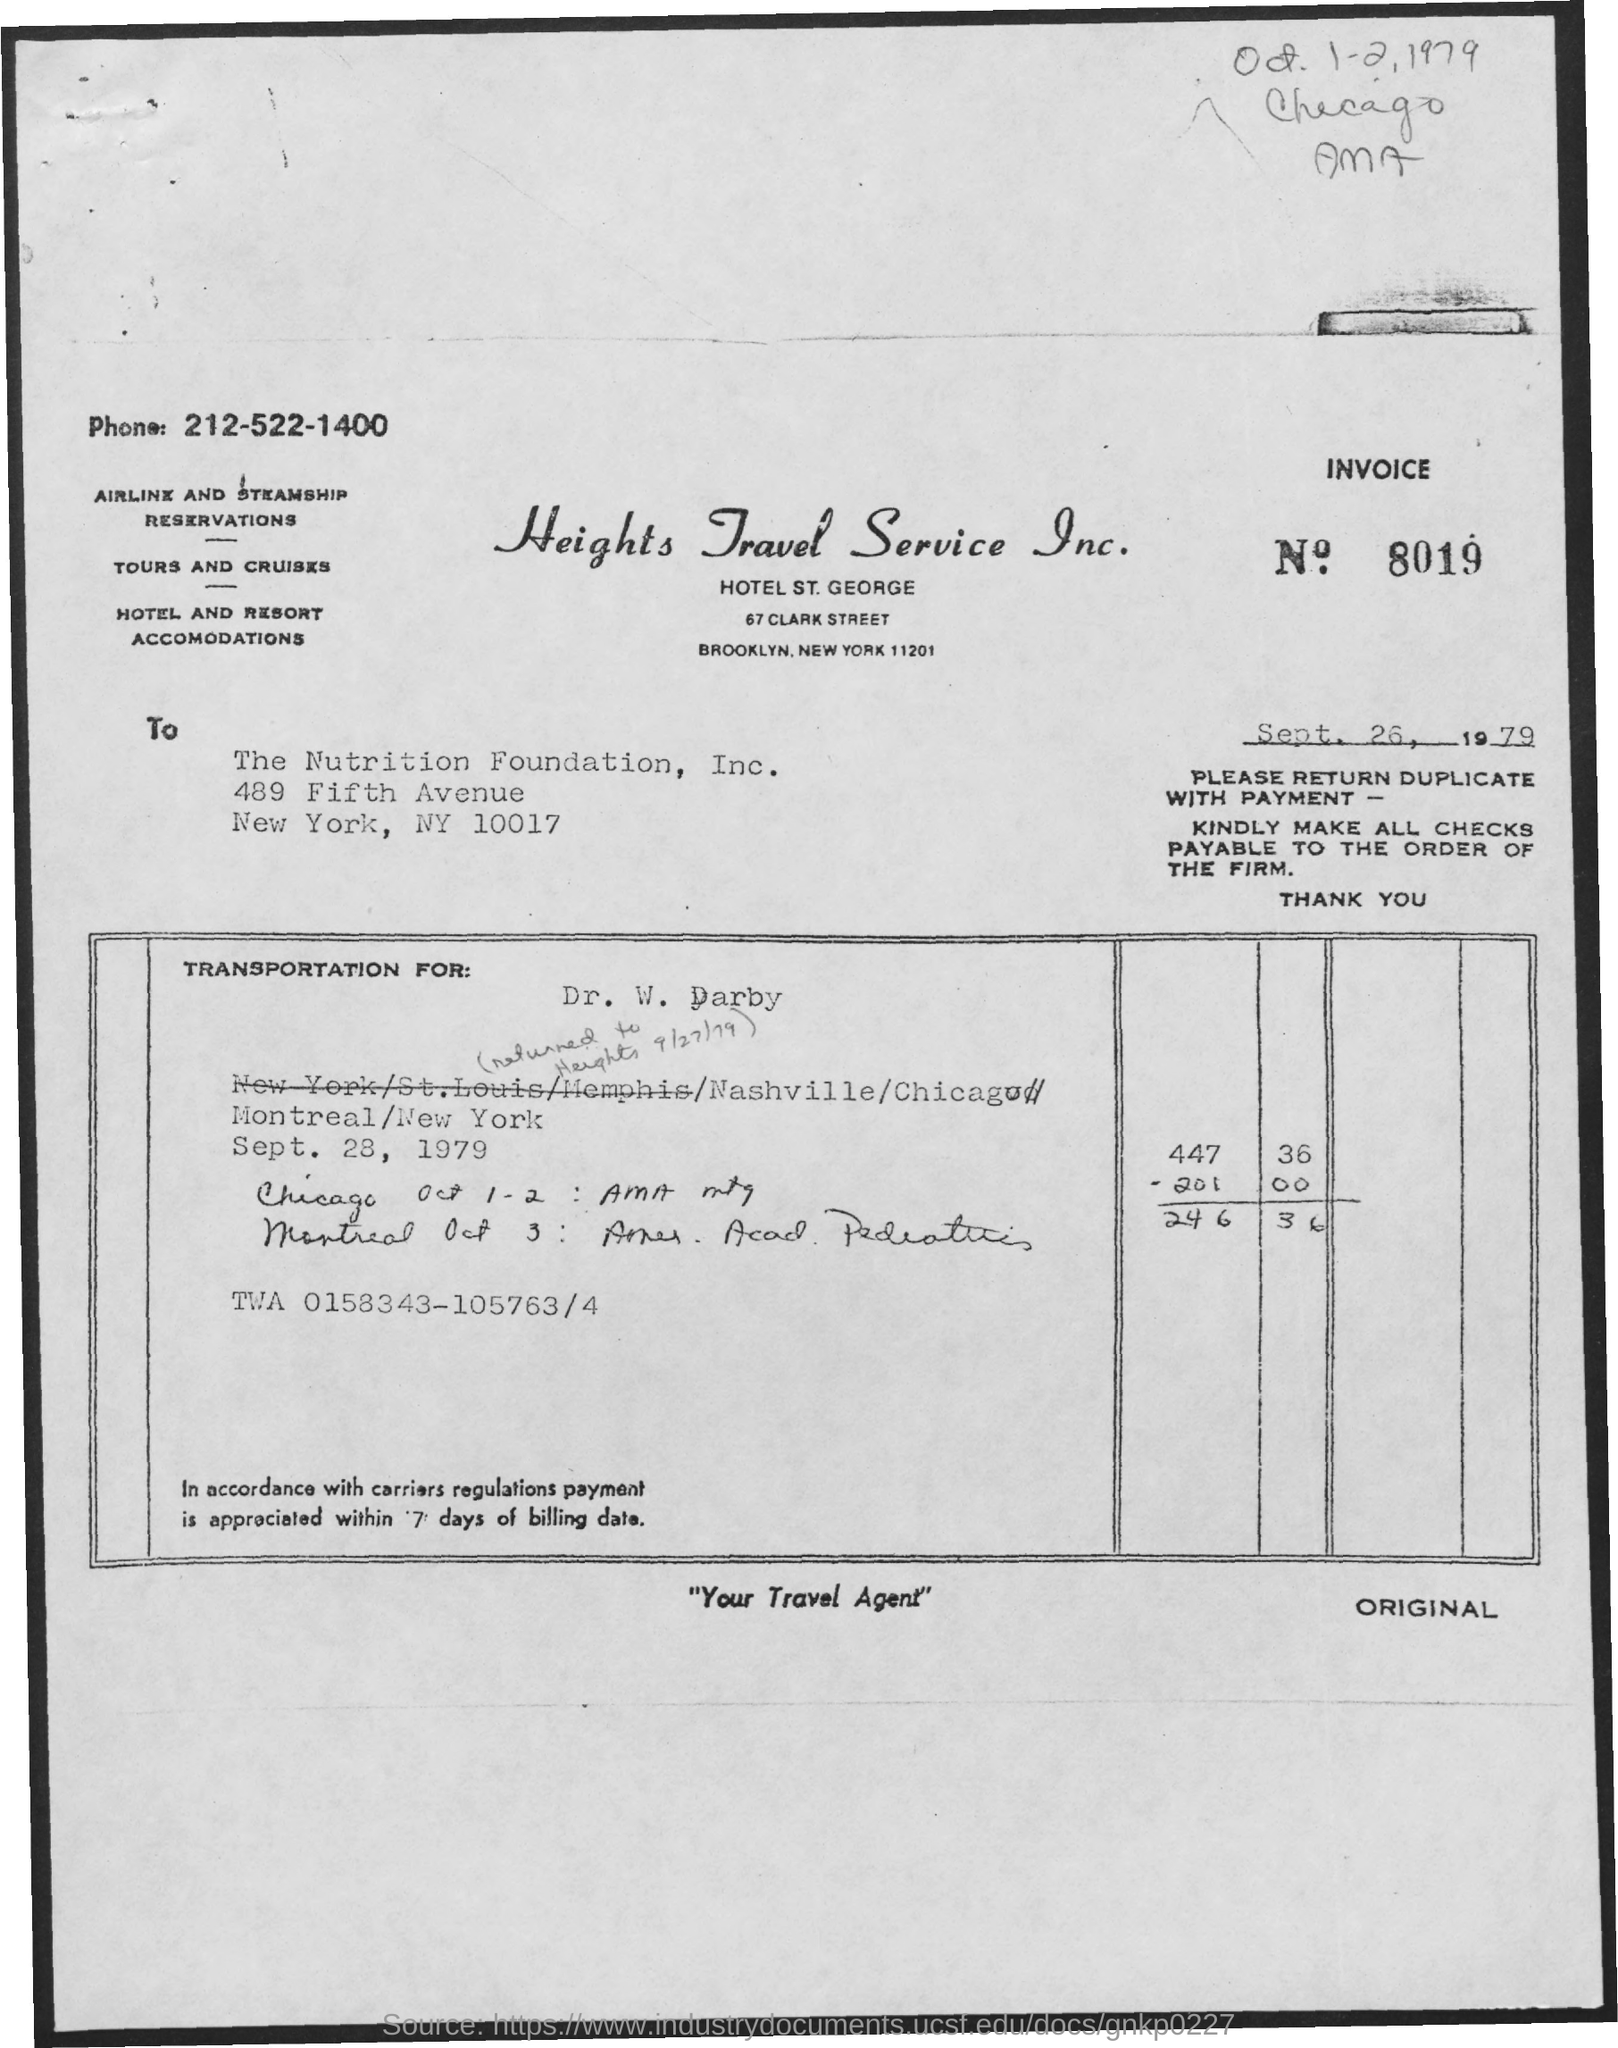Point out several critical features in this image. The invoice number mentioned in this document is 8019... The issued date of the invoice is September 26, 1979. The invoice is addressed to the Nutrition Foundation, Inc. 